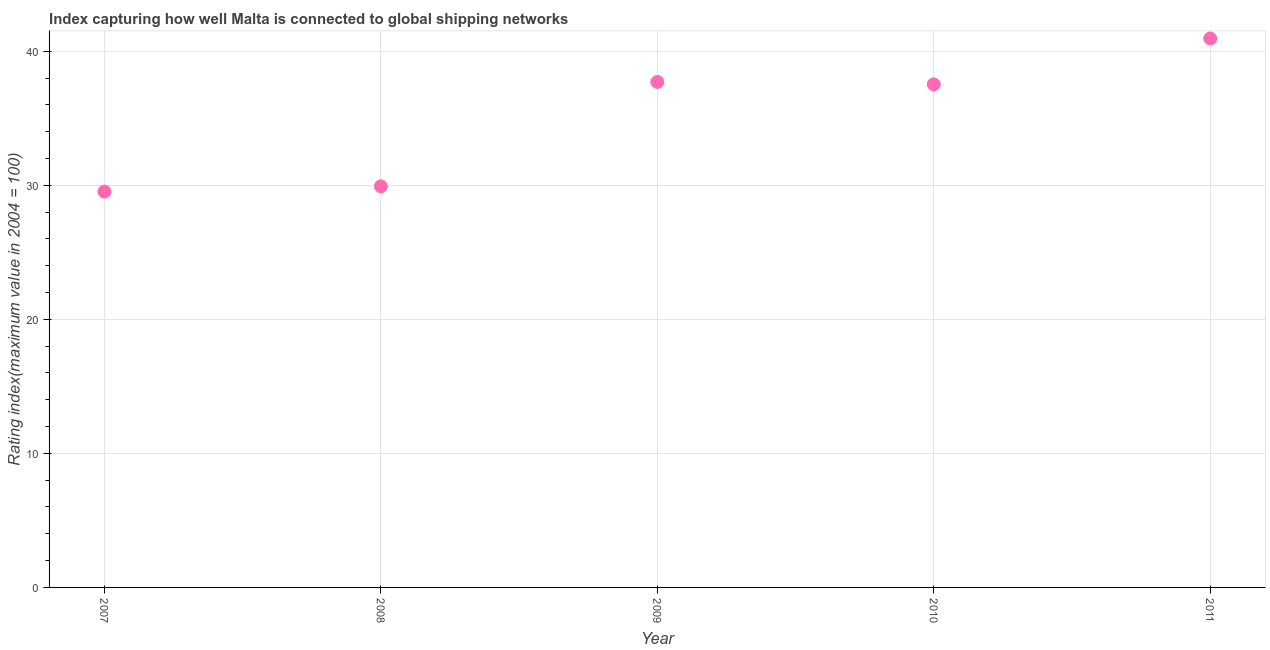What is the liner shipping connectivity index in 2007?
Offer a very short reply. 29.53. Across all years, what is the maximum liner shipping connectivity index?
Give a very brief answer. 40.95. Across all years, what is the minimum liner shipping connectivity index?
Offer a very short reply. 29.53. In which year was the liner shipping connectivity index maximum?
Ensure brevity in your answer.  2011. In which year was the liner shipping connectivity index minimum?
Make the answer very short. 2007. What is the sum of the liner shipping connectivity index?
Offer a terse response. 175.64. What is the difference between the liner shipping connectivity index in 2007 and 2009?
Your response must be concise. -8.18. What is the average liner shipping connectivity index per year?
Offer a terse response. 35.13. What is the median liner shipping connectivity index?
Provide a short and direct response. 37.53. In how many years, is the liner shipping connectivity index greater than 20 ?
Make the answer very short. 5. Do a majority of the years between 2009 and 2010 (inclusive) have liner shipping connectivity index greater than 26 ?
Give a very brief answer. Yes. What is the ratio of the liner shipping connectivity index in 2010 to that in 2011?
Your answer should be compact. 0.92. Is the liner shipping connectivity index in 2007 less than that in 2009?
Offer a very short reply. Yes. What is the difference between the highest and the second highest liner shipping connectivity index?
Make the answer very short. 3.24. Is the sum of the liner shipping connectivity index in 2007 and 2008 greater than the maximum liner shipping connectivity index across all years?
Your answer should be very brief. Yes. What is the difference between the highest and the lowest liner shipping connectivity index?
Give a very brief answer. 11.42. How many dotlines are there?
Your answer should be compact. 1. Does the graph contain any zero values?
Provide a succinct answer. No. What is the title of the graph?
Your response must be concise. Index capturing how well Malta is connected to global shipping networks. What is the label or title of the X-axis?
Your response must be concise. Year. What is the label or title of the Y-axis?
Provide a succinct answer. Rating index(maximum value in 2004 = 100). What is the Rating index(maximum value in 2004 = 100) in 2007?
Make the answer very short. 29.53. What is the Rating index(maximum value in 2004 = 100) in 2008?
Give a very brief answer. 29.92. What is the Rating index(maximum value in 2004 = 100) in 2009?
Offer a very short reply. 37.71. What is the Rating index(maximum value in 2004 = 100) in 2010?
Your answer should be very brief. 37.53. What is the Rating index(maximum value in 2004 = 100) in 2011?
Your response must be concise. 40.95. What is the difference between the Rating index(maximum value in 2004 = 100) in 2007 and 2008?
Your answer should be very brief. -0.39. What is the difference between the Rating index(maximum value in 2004 = 100) in 2007 and 2009?
Give a very brief answer. -8.18. What is the difference between the Rating index(maximum value in 2004 = 100) in 2007 and 2010?
Provide a succinct answer. -8. What is the difference between the Rating index(maximum value in 2004 = 100) in 2007 and 2011?
Your response must be concise. -11.42. What is the difference between the Rating index(maximum value in 2004 = 100) in 2008 and 2009?
Your answer should be very brief. -7.79. What is the difference between the Rating index(maximum value in 2004 = 100) in 2008 and 2010?
Provide a short and direct response. -7.61. What is the difference between the Rating index(maximum value in 2004 = 100) in 2008 and 2011?
Provide a short and direct response. -11.03. What is the difference between the Rating index(maximum value in 2004 = 100) in 2009 and 2010?
Make the answer very short. 0.18. What is the difference between the Rating index(maximum value in 2004 = 100) in 2009 and 2011?
Your answer should be compact. -3.24. What is the difference between the Rating index(maximum value in 2004 = 100) in 2010 and 2011?
Offer a terse response. -3.42. What is the ratio of the Rating index(maximum value in 2004 = 100) in 2007 to that in 2009?
Offer a terse response. 0.78. What is the ratio of the Rating index(maximum value in 2004 = 100) in 2007 to that in 2010?
Offer a terse response. 0.79. What is the ratio of the Rating index(maximum value in 2004 = 100) in 2007 to that in 2011?
Offer a terse response. 0.72. What is the ratio of the Rating index(maximum value in 2004 = 100) in 2008 to that in 2009?
Ensure brevity in your answer.  0.79. What is the ratio of the Rating index(maximum value in 2004 = 100) in 2008 to that in 2010?
Make the answer very short. 0.8. What is the ratio of the Rating index(maximum value in 2004 = 100) in 2008 to that in 2011?
Keep it short and to the point. 0.73. What is the ratio of the Rating index(maximum value in 2004 = 100) in 2009 to that in 2010?
Your answer should be very brief. 1. What is the ratio of the Rating index(maximum value in 2004 = 100) in 2009 to that in 2011?
Provide a short and direct response. 0.92. What is the ratio of the Rating index(maximum value in 2004 = 100) in 2010 to that in 2011?
Your answer should be compact. 0.92. 